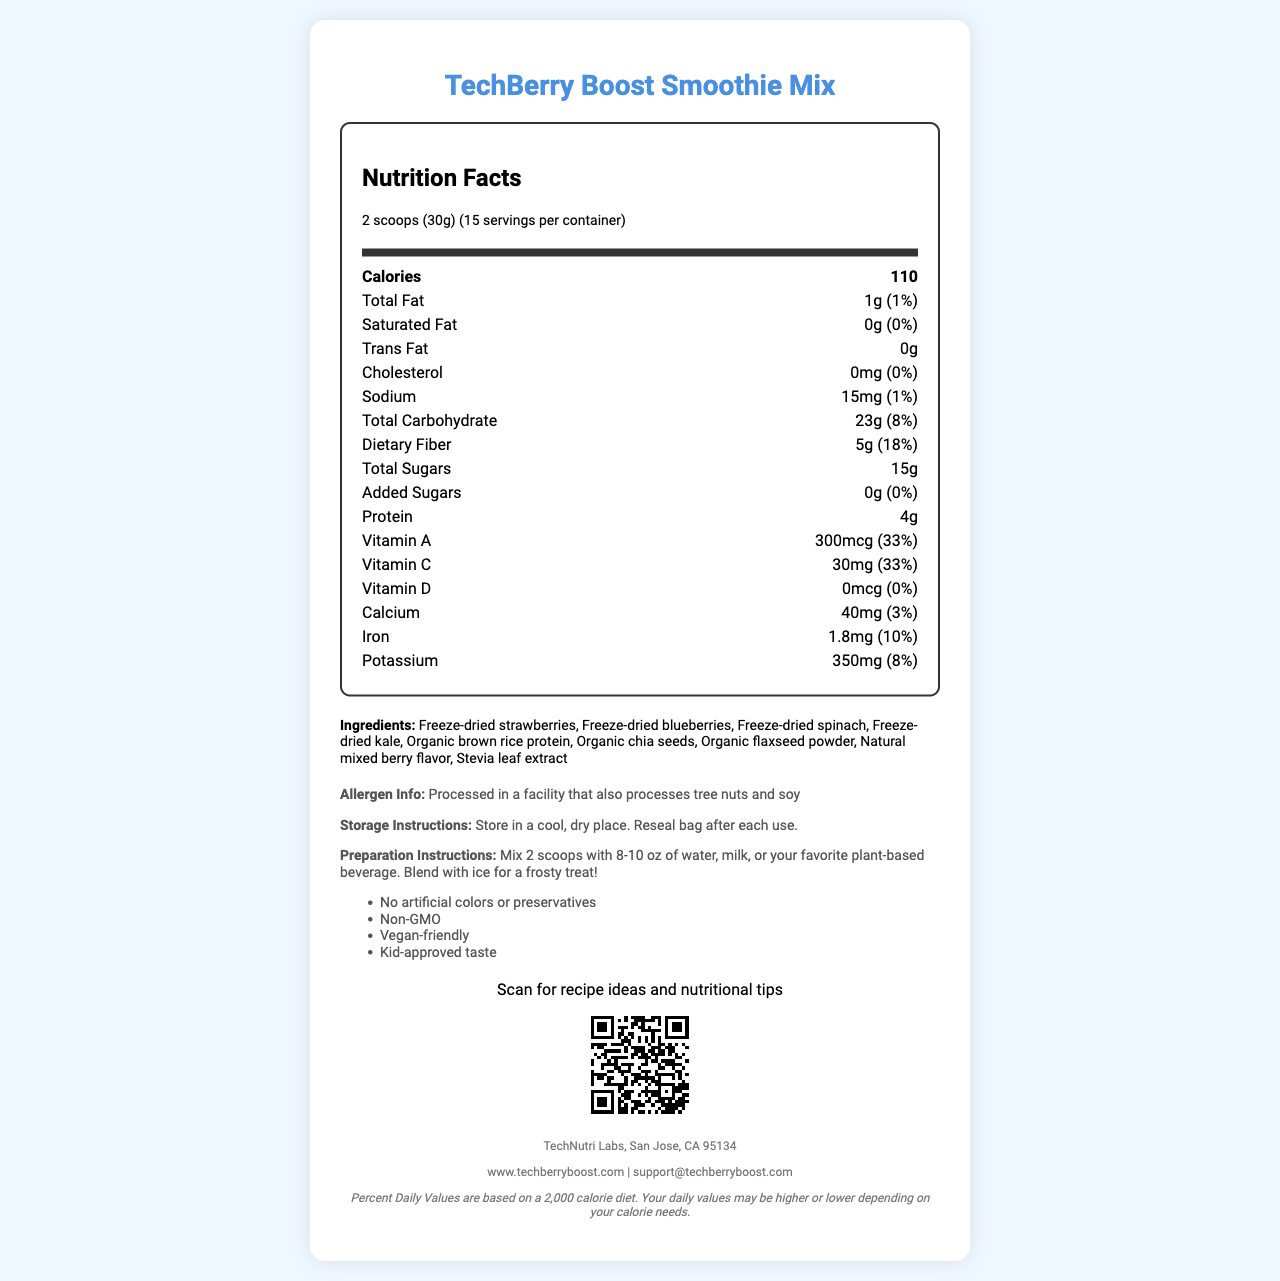what is the product name? The product name "TechBerry Boost Smoothie Mix" is prominently displayed at the top of the document.
Answer: TechBerry Boost Smoothie Mix how many servings are there per container? The label clearly states that there are 15 servings per container.
Answer: 15 how many calories are in a serving? The number of calories per serving is listed as 110 in the nutrition facts section.
Answer: 110 what is the total fat content per serving? The nutrition facts label specifies that the total fat content per serving is 1g.
Answer: 1g what is the serving size? The serving size is noted as "2 scoops (30g)" in the serving information section.
Answer: 2 scoops (30g) how much dietary fiber is in a serving? The dietary fiber per serving is listed as 5g.
Answer: 5g how much calcium is in a serving? The amount of calcium per serving is 40mg, as found in the nutrition facts.
Answer: 40mg does this product contain any added sugars? The nutrition facts section indicates that the amount of added sugars is 0g.
Answer: No what is the daily value percentage of iron? The document lists the iron daily value percentage as 10%.
Answer: 10% how should this smoothie mix be stored? The storage instructions state to store the mix in a cool, dry place and to reseal the bag after each use.
Answer: Store in a cool, dry place. Reseal bag after each use. Which of the following is an ingredient in the smoothie mix? A. Freeze-dried strawberries B. Essential oils C. High fructose corn syrup The ingredient list includes "Freeze-dried strawberries" but does not mention essential oils or high fructose corn syrup.
Answer: A What is the percentage daily value of Vitamin A per serving? (A) 10% (B) 20% (C) 33% (D) 50% The daily value percentage of Vitamin A is listed as 33% in the nutrition facts section.
Answer: C Is the product vegan-friendly? The document lists "Vegan-friendly" in the additional information section.
Answer: Yes summarize the main idea of the document. The document covers various aspects of the TechBerry Boost Smoothie Mix to inform consumers about its nutritional benefits, ingredients, and usage instructions.
Answer: The document provides nutrition facts and other essential details about TechBerry Boost Smoothie Mix. It includes information about serving size, calorie content, nutrients, ingredients, allergen info, storage and preparation instructions, and additional product features like being non-GMO and vegan-friendly. how much potassium does a serving contain? According to the nutrition facts section, a serving contains 350mg of potassium.
Answer: 350mg is there any cholesterol in the smoothie mix? The nutrition facts label shows that the amount of cholesterol is 0mg, indicating there is no cholesterol in the mix.
Answer: No who manufactures this product? The footer of the document mentions that the product is manufactured by TechNutri Labs, San Jose, CA 95134.
Answer: TechNutri Labs, San Jose, CA 95134 how much protein is in a serving? The amount of protein per serving is listed as 4g in the nutrition facts.
Answer: 4g What is advised to do with the mix for a frosty treat? (A) Freeze it (B) Mix with warm water (C) Blend with ice The preparation instructions suggest blending the mix with ice for a frosty treat.
Answer: C how many grams of total carbohydrates are in a serving? The total carbohydrate content per serving is listed as 23g in the nutrition facts section.
Answer: 23g does the product contain any artificial colors or preservatives? The additional information section states that the product contains no artificial colors or preservatives.
Answer: No What is the exact added sugar amount according to the nutrition label? The added sugar amount is precisely stated as 0g in the nutrition facts section.
Answer: 0g Can the protein source in this mix be determined in the document? The ingredient list includes "Organic brown rice protein", indicating the protein source.
Answer: Yes What is the purpose of scanning the QR code on the document? The text beneath the QR code indicates that scanning it will provide recipe ideas and nutritional tips.
Answer: Scan for recipe ideas and nutritional tips Does this product contain tree nuts? The allergen info states that it is processed in a facility that also processes tree nuts and soy, but does not specify if the product itself contains tree nuts.
Answer: Cannot be determined 